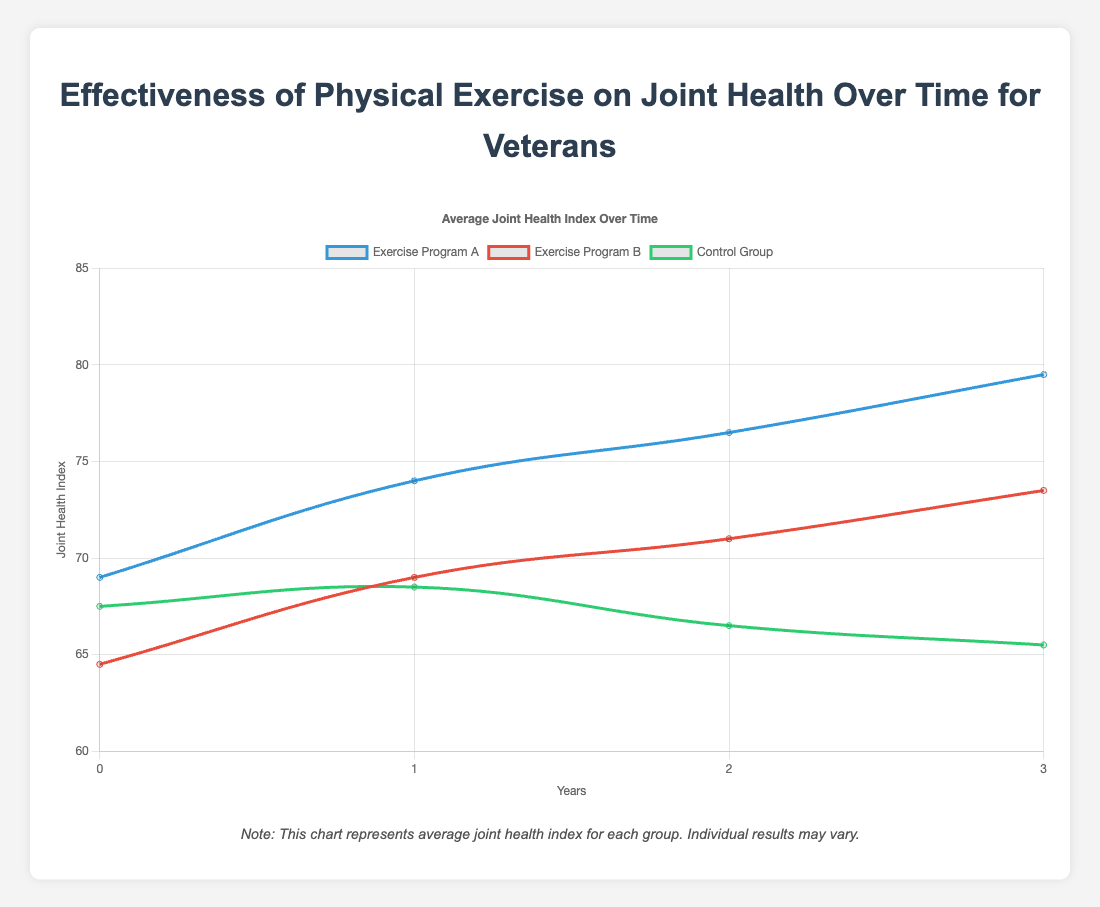Which exercise program shows the greatest improvement in joint health over three years? The improvement is calculated as the difference between the joint health index at year 3 and year 0 for each program. 
For Exercise Program A: (80 - 70) = 10 for John Doe and (79 - 68) = 11 for Emily Brown, average improvement = (10 + 11) / 2 = 10.5
For Exercise Program B: (74 - 65) = 9 for Jane Smith and (73 - 64) = 9 for Patricia Martinez, average improvement = (9 + 9) / 2 = 9
For the Control Group: (64 - 66) = -2 for Michael Johnson and (67 - 69) = -2 for William Davis, average improvement = (-2 + -2) / 2 = -2
Exercise Program A shows the greatest improvement.
Answer: Exercise Program A Was there any group that experienced a decline in joint health over the three years? We need to check the joint health index at year 3 compared to year 0 for each group.
For the Control Group: Michael Johnson (64, down from 66) and William Davis (67, down from 69); both individuals in the Control Group experienced declines.
Thus, the Control Group experienced a decline.
Answer: Control Group Between Exercise Program A and Exercise Program B, which program had a higher joint health index in year 2? Compare the average joint health index for year 2 between the two programs.
For Exercise Program A: John Doe (77) and Emily Brown (76), average = (77 + 76) / 2 = 76.5
For Exercise Program B: Jane Smith (72) and Patricia Martinez (70), average = (72 + 70) / 2 = 71
Exercise Program A had a higher joint health index in year 2.
Answer: Exercise Program A How does the joint health index of the Control Group change over the years? Track the change in joint health index for the Control Group over the years 0 to 3.
For Michael Johnson: 66 in year 0, 67 in year 1, 65 in year 2, and 64 in year 3
For William Davis: 69 in year 0, 70 in year 1, 68 in year 2, and 67 in year 3
The Control Group starts higher, peaks the first year but declines over the years.
Answer: Declines Which group has the highest joint health index in year 1? Compare the joint health index of all groups in year 1.
Exercise Program A: John Doe (75) and Emily Brown (73), average = (75 + 73) / 2 = 74
Exercise Program B: Jane Smith (70) and Patricia Martinez (68), average = (70 + 68) / 2 = 69
Control Group: Michael Johnson (67) and William Davis (70), average = (67 + 70) / 2 = 68.5
Exercise Program A has the highest average joint health index in year 1.
Answer: Exercise Program A 